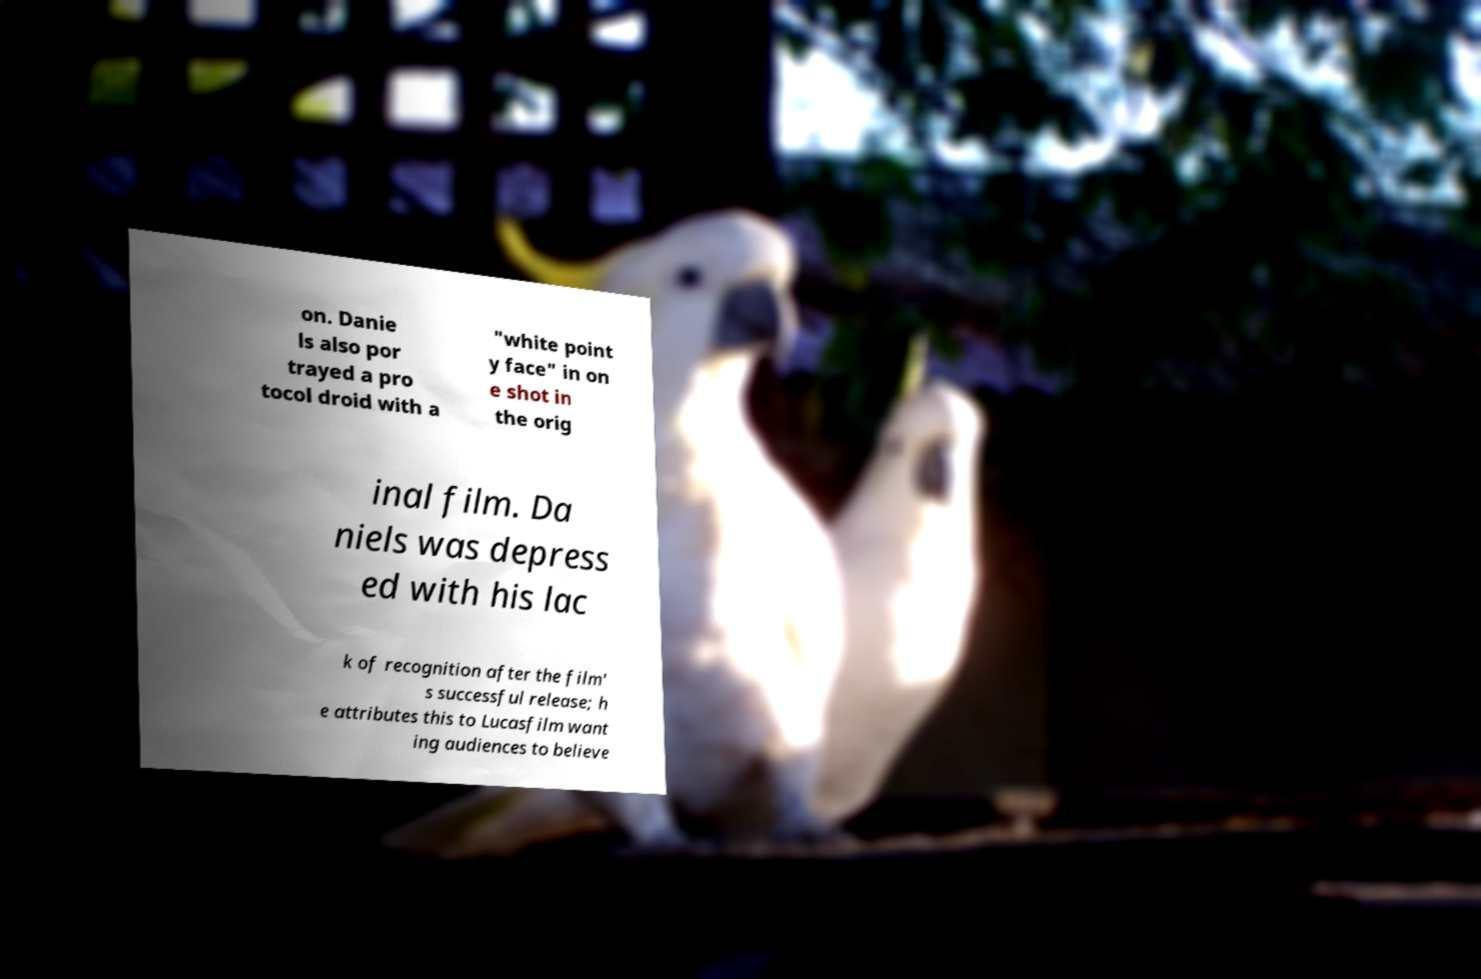Please identify and transcribe the text found in this image. on. Danie ls also por trayed a pro tocol droid with a "white point y face" in on e shot in the orig inal film. Da niels was depress ed with his lac k of recognition after the film' s successful release; h e attributes this to Lucasfilm want ing audiences to believe 